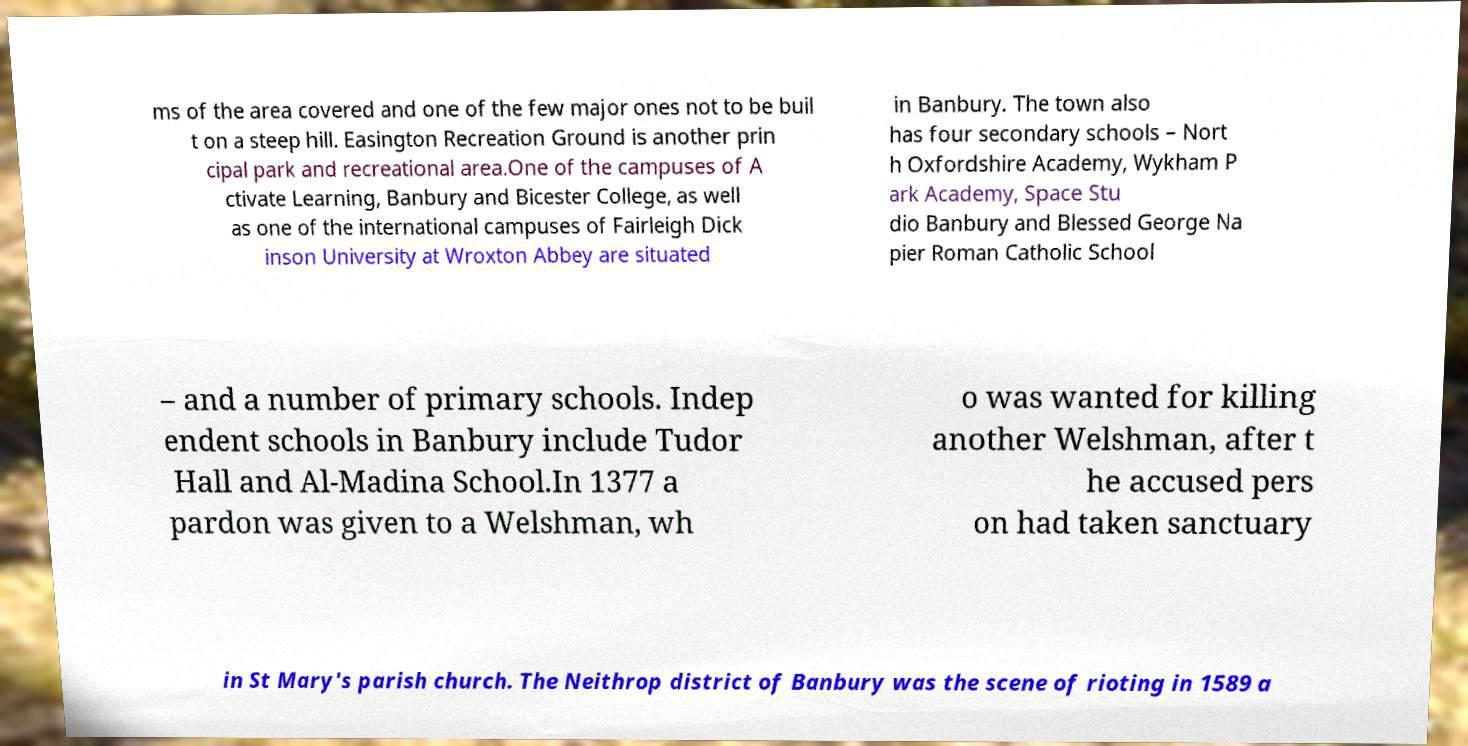Could you extract and type out the text from this image? ms of the area covered and one of the few major ones not to be buil t on a steep hill. Easington Recreation Ground is another prin cipal park and recreational area.One of the campuses of A ctivate Learning, Banbury and Bicester College, as well as one of the international campuses of Fairleigh Dick inson University at Wroxton Abbey are situated in Banbury. The town also has four secondary schools – Nort h Oxfordshire Academy, Wykham P ark Academy, Space Stu dio Banbury and Blessed George Na pier Roman Catholic School – and a number of primary schools. Indep endent schools in Banbury include Tudor Hall and Al-Madina School.In 1377 a pardon was given to a Welshman, wh o was wanted for killing another Welshman, after t he accused pers on had taken sanctuary in St Mary's parish church. The Neithrop district of Banbury was the scene of rioting in 1589 a 